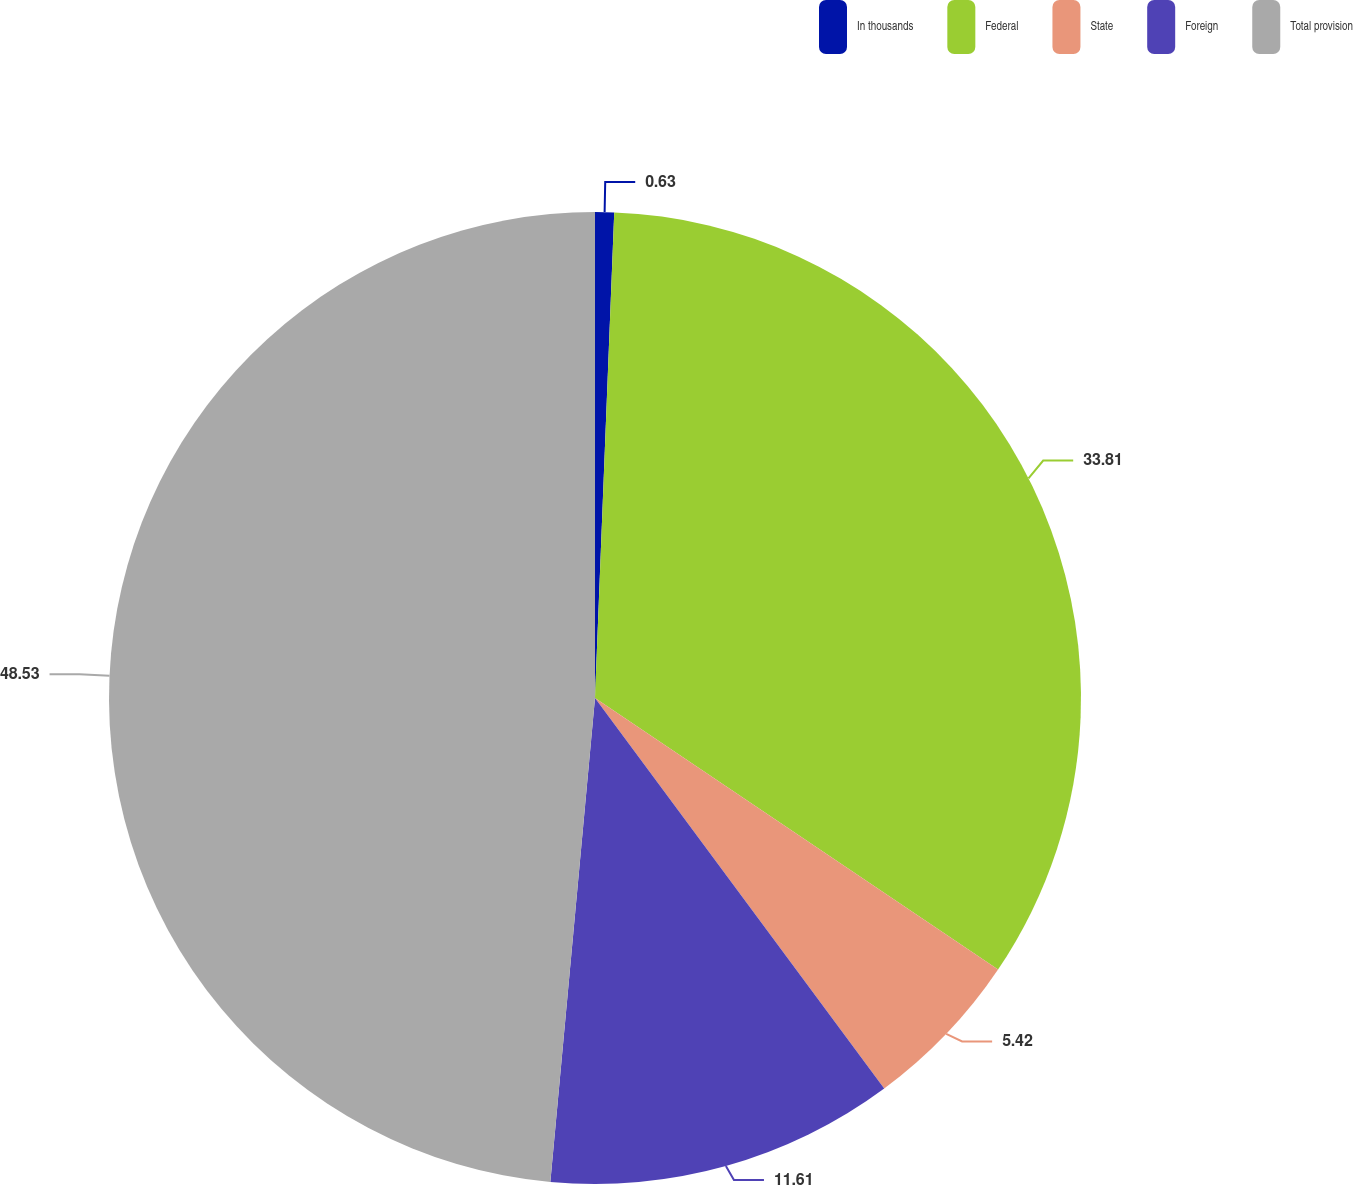<chart> <loc_0><loc_0><loc_500><loc_500><pie_chart><fcel>In thousands<fcel>Federal<fcel>State<fcel>Foreign<fcel>Total provision<nl><fcel>0.63%<fcel>33.81%<fcel>5.42%<fcel>11.61%<fcel>48.54%<nl></chart> 